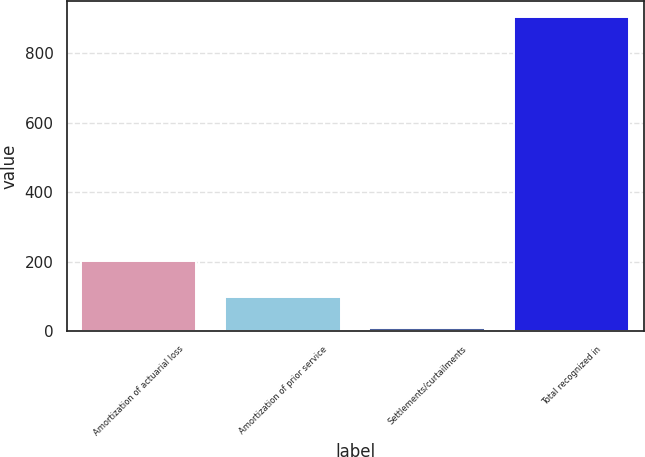<chart> <loc_0><loc_0><loc_500><loc_500><bar_chart><fcel>Amortization of actuarial loss<fcel>Amortization of prior service<fcel>Settlements/curtailments<fcel>Total recognized in<nl><fcel>202<fcel>99.5<fcel>10<fcel>905<nl></chart> 